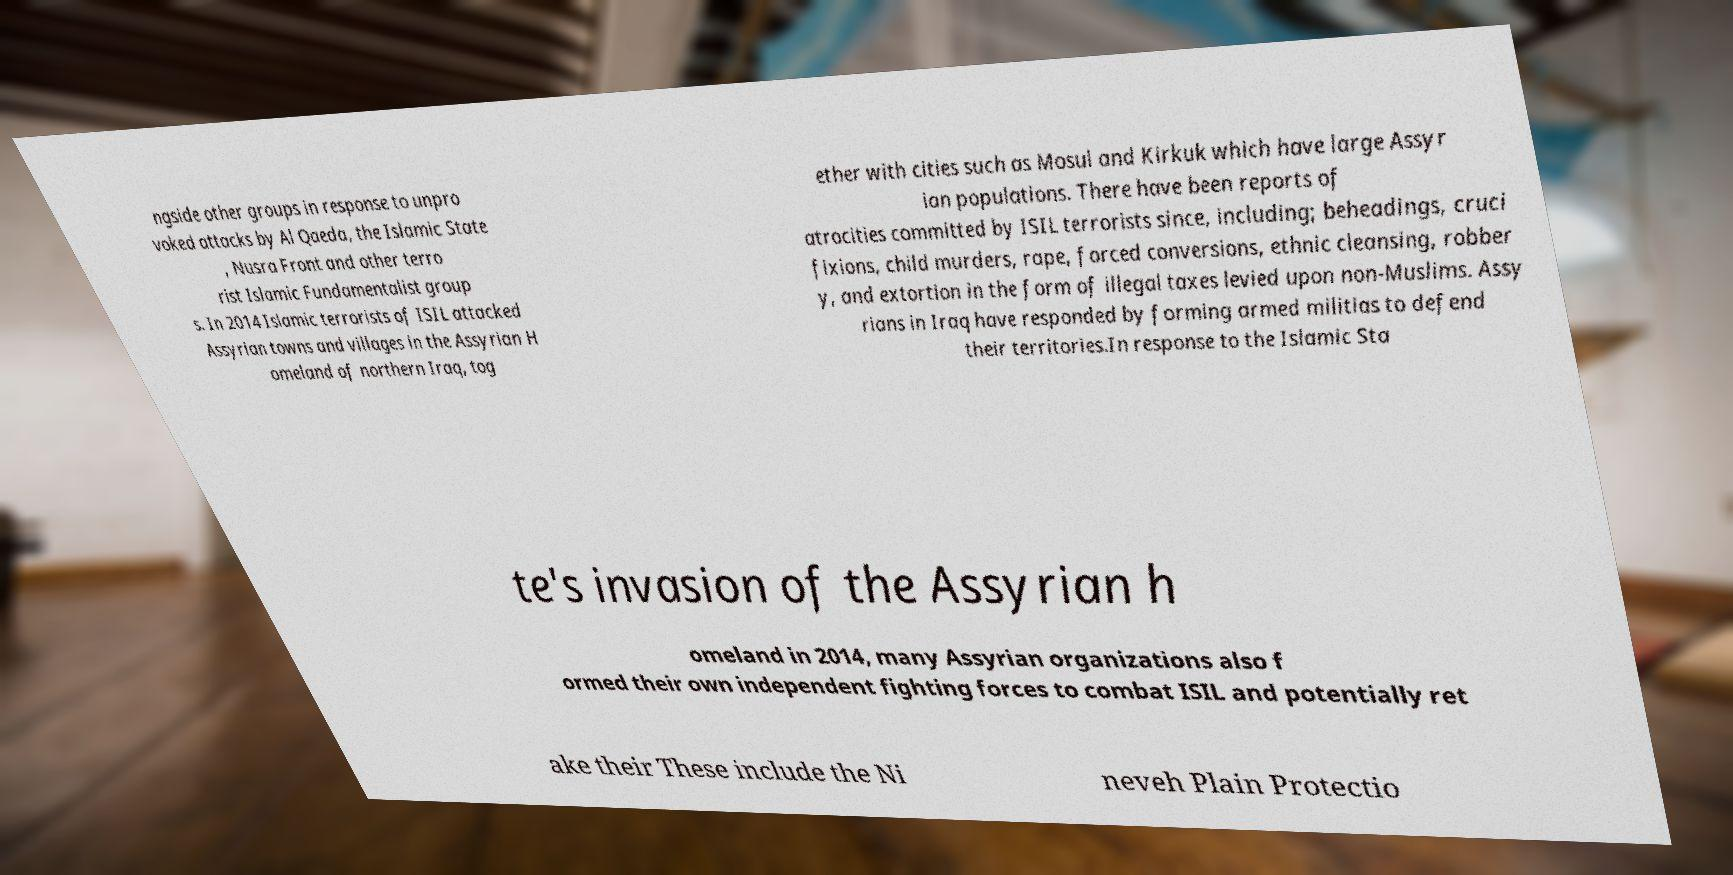Please read and relay the text visible in this image. What does it say? ngside other groups in response to unpro voked attacks by Al Qaeda, the Islamic State , Nusra Front and other terro rist Islamic Fundamentalist group s. In 2014 Islamic terrorists of ISIL attacked Assyrian towns and villages in the Assyrian H omeland of northern Iraq, tog ether with cities such as Mosul and Kirkuk which have large Assyr ian populations. There have been reports of atrocities committed by ISIL terrorists since, including; beheadings, cruci fixions, child murders, rape, forced conversions, ethnic cleansing, robber y, and extortion in the form of illegal taxes levied upon non-Muslims. Assy rians in Iraq have responded by forming armed militias to defend their territories.In response to the Islamic Sta te's invasion of the Assyrian h omeland in 2014, many Assyrian organizations also f ormed their own independent fighting forces to combat ISIL and potentially ret ake their These include the Ni neveh Plain Protectio 